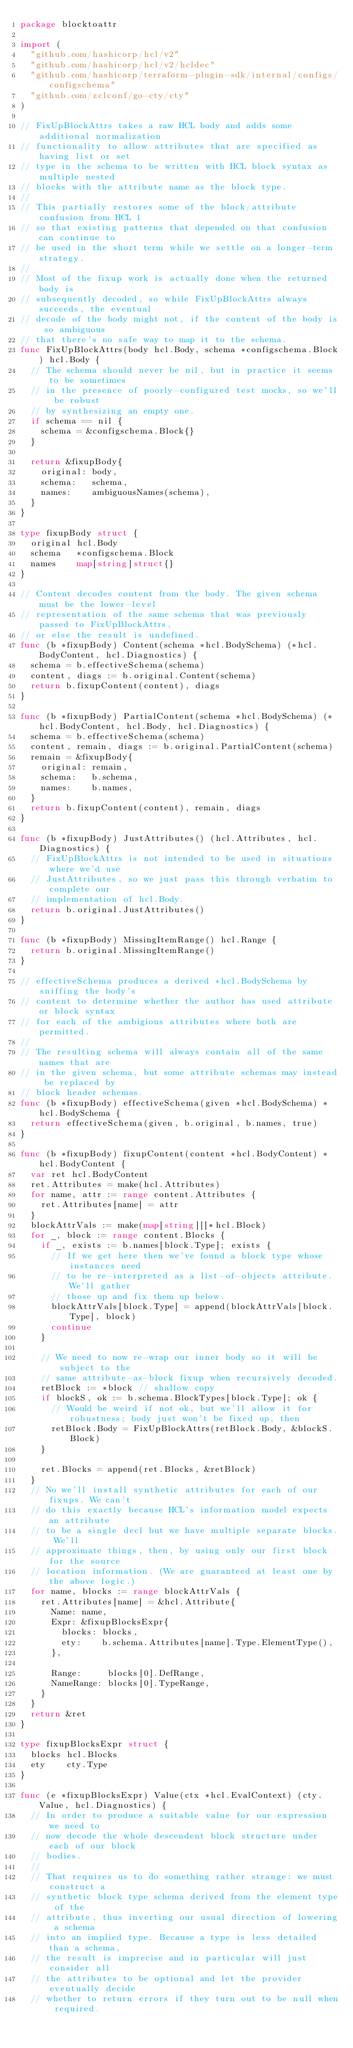Convert code to text. <code><loc_0><loc_0><loc_500><loc_500><_Go_>package blocktoattr

import (
	"github.com/hashicorp/hcl/v2"
	"github.com/hashicorp/hcl/v2/hcldec"
	"github.com/hashicorp/terraform-plugin-sdk/internal/configs/configschema"
	"github.com/zclconf/go-cty/cty"
)

// FixUpBlockAttrs takes a raw HCL body and adds some additional normalization
// functionality to allow attributes that are specified as having list or set
// type in the schema to be written with HCL block syntax as multiple nested
// blocks with the attribute name as the block type.
//
// This partially restores some of the block/attribute confusion from HCL 1
// so that existing patterns that depended on that confusion can continue to
// be used in the short term while we settle on a longer-term strategy.
//
// Most of the fixup work is actually done when the returned body is
// subsequently decoded, so while FixUpBlockAttrs always succeeds, the eventual
// decode of the body might not, if the content of the body is so ambiguous
// that there's no safe way to map it to the schema.
func FixUpBlockAttrs(body hcl.Body, schema *configschema.Block) hcl.Body {
	// The schema should never be nil, but in practice it seems to be sometimes
	// in the presence of poorly-configured test mocks, so we'll be robust
	// by synthesizing an empty one.
	if schema == nil {
		schema = &configschema.Block{}
	}

	return &fixupBody{
		original: body,
		schema:   schema,
		names:    ambiguousNames(schema),
	}
}

type fixupBody struct {
	original hcl.Body
	schema   *configschema.Block
	names    map[string]struct{}
}

// Content decodes content from the body. The given schema must be the lower-level
// representation of the same schema that was previously passed to FixUpBlockAttrs,
// or else the result is undefined.
func (b *fixupBody) Content(schema *hcl.BodySchema) (*hcl.BodyContent, hcl.Diagnostics) {
	schema = b.effectiveSchema(schema)
	content, diags := b.original.Content(schema)
	return b.fixupContent(content), diags
}

func (b *fixupBody) PartialContent(schema *hcl.BodySchema) (*hcl.BodyContent, hcl.Body, hcl.Diagnostics) {
	schema = b.effectiveSchema(schema)
	content, remain, diags := b.original.PartialContent(schema)
	remain = &fixupBody{
		original: remain,
		schema:   b.schema,
		names:    b.names,
	}
	return b.fixupContent(content), remain, diags
}

func (b *fixupBody) JustAttributes() (hcl.Attributes, hcl.Diagnostics) {
	// FixUpBlockAttrs is not intended to be used in situations where we'd use
	// JustAttributes, so we just pass this through verbatim to complete our
	// implementation of hcl.Body.
	return b.original.JustAttributes()
}

func (b *fixupBody) MissingItemRange() hcl.Range {
	return b.original.MissingItemRange()
}

// effectiveSchema produces a derived *hcl.BodySchema by sniffing the body's
// content to determine whether the author has used attribute or block syntax
// for each of the ambigious attributes where both are permitted.
//
// The resulting schema will always contain all of the same names that are
// in the given schema, but some attribute schemas may instead be replaced by
// block header schemas.
func (b *fixupBody) effectiveSchema(given *hcl.BodySchema) *hcl.BodySchema {
	return effectiveSchema(given, b.original, b.names, true)
}

func (b *fixupBody) fixupContent(content *hcl.BodyContent) *hcl.BodyContent {
	var ret hcl.BodyContent
	ret.Attributes = make(hcl.Attributes)
	for name, attr := range content.Attributes {
		ret.Attributes[name] = attr
	}
	blockAttrVals := make(map[string][]*hcl.Block)
	for _, block := range content.Blocks {
		if _, exists := b.names[block.Type]; exists {
			// If we get here then we've found a block type whose instances need
			// to be re-interpreted as a list-of-objects attribute. We'll gather
			// those up and fix them up below.
			blockAttrVals[block.Type] = append(blockAttrVals[block.Type], block)
			continue
		}

		// We need to now re-wrap our inner body so it will be subject to the
		// same attribute-as-block fixup when recursively decoded.
		retBlock := *block // shallow copy
		if blockS, ok := b.schema.BlockTypes[block.Type]; ok {
			// Would be weird if not ok, but we'll allow it for robustness; body just won't be fixed up, then
			retBlock.Body = FixUpBlockAttrs(retBlock.Body, &blockS.Block)
		}

		ret.Blocks = append(ret.Blocks, &retBlock)
	}
	// No we'll install synthetic attributes for each of our fixups. We can't
	// do this exactly because HCL's information model expects an attribute
	// to be a single decl but we have multiple separate blocks. We'll
	// approximate things, then, by using only our first block for the source
	// location information. (We are guaranteed at least one by the above logic.)
	for name, blocks := range blockAttrVals {
		ret.Attributes[name] = &hcl.Attribute{
			Name: name,
			Expr: &fixupBlocksExpr{
				blocks: blocks,
				ety:    b.schema.Attributes[name].Type.ElementType(),
			},

			Range:     blocks[0].DefRange,
			NameRange: blocks[0].TypeRange,
		}
	}
	return &ret
}

type fixupBlocksExpr struct {
	blocks hcl.Blocks
	ety    cty.Type
}

func (e *fixupBlocksExpr) Value(ctx *hcl.EvalContext) (cty.Value, hcl.Diagnostics) {
	// In order to produce a suitable value for our expression we need to
	// now decode the whole descendent block structure under each of our block
	// bodies.
	//
	// That requires us to do something rather strange: we must construct a
	// synthetic block type schema derived from the element type of the
	// attribute, thus inverting our usual direction of lowering a schema
	// into an implied type. Because a type is less detailed than a schema,
	// the result is imprecise and in particular will just consider all
	// the attributes to be optional and let the provider eventually decide
	// whether to return errors if they turn out to be null when required.</code> 